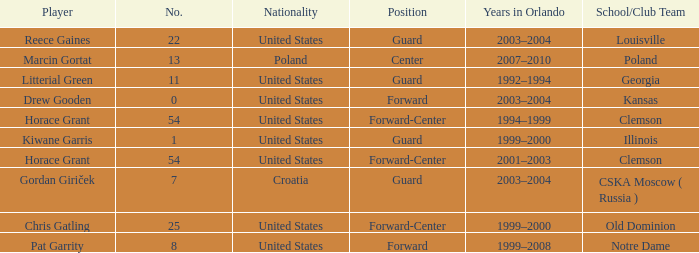What is Chris Gatling 's number? 25.0. 